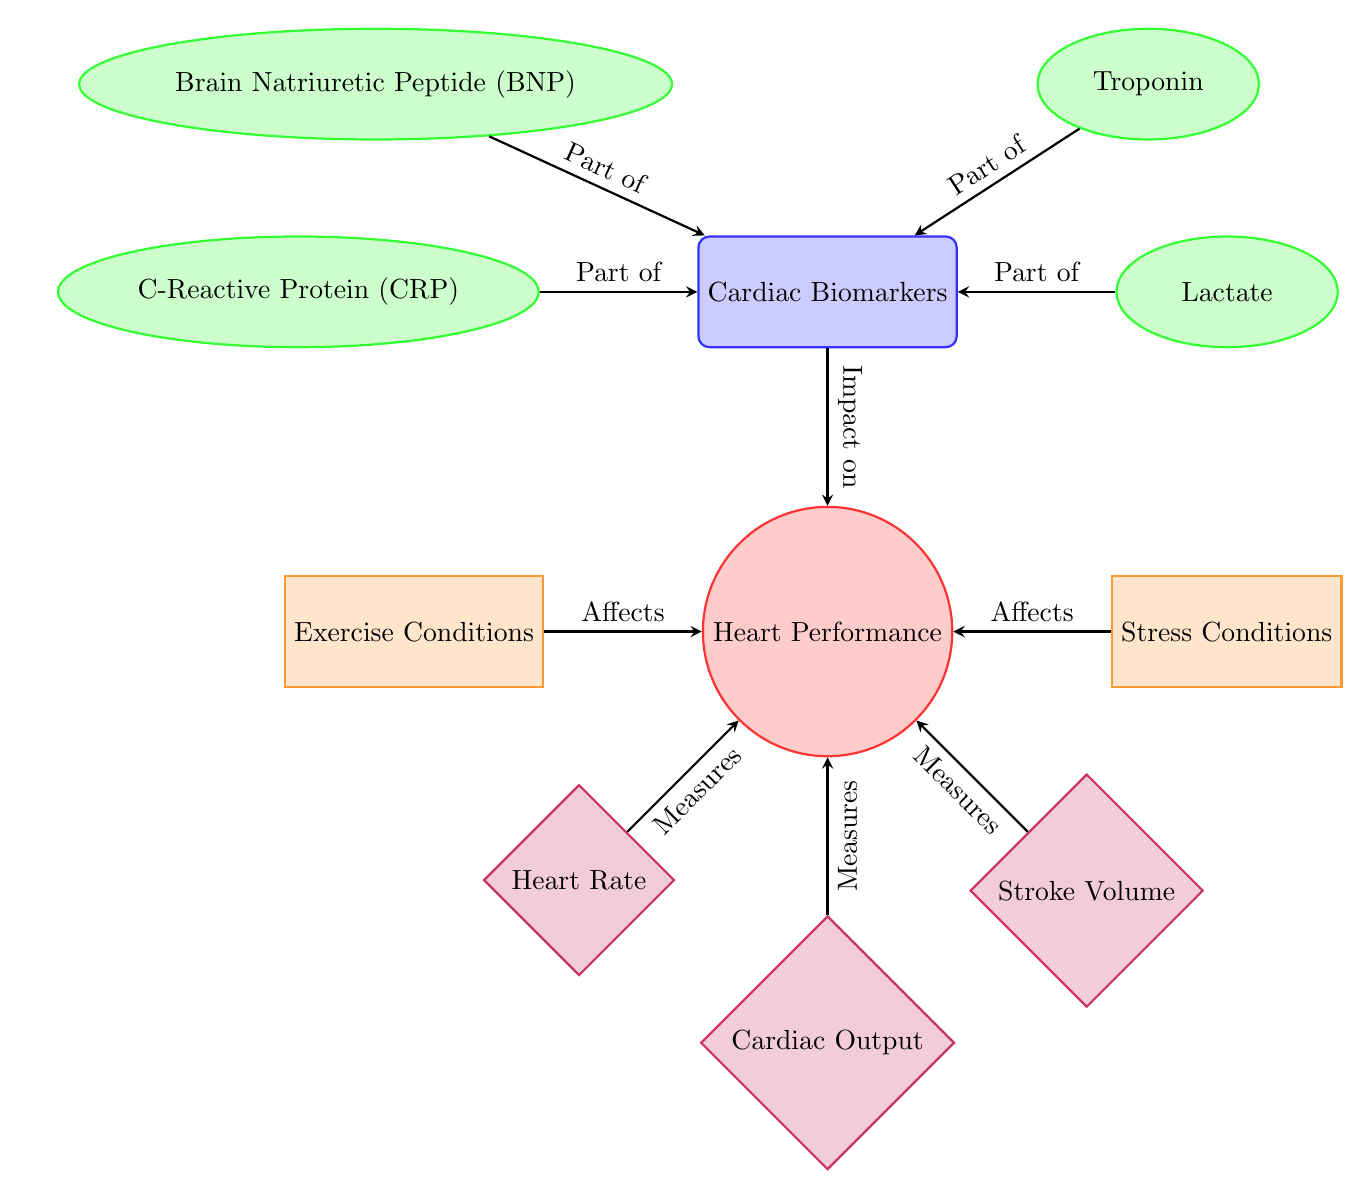What's the central node of the diagram? The diagram identifies "Heart Performance" as the central node, which is positioned prominently at the center.
Answer: Heart Performance How many cardiac biomarkers are listed in the diagram? There are four cardiac biomarkers indicated in the diagram: Brain Natriuretic Peptide (BNP), Troponin, C-Reactive Protein (CRP), and Lactate.
Answer: Four What does the "Heart Rate" measure? The diagram specifies that "Heart Rate" measures the central node, which signifies "Heart Performance".
Answer: Measures Which external condition affects heart performance according to the diagram? The diagram illustrates that both "Exercise Conditions" and "Stress Conditions" affect heart performance, indicating external influences on the heart's efficiency.
Answer: Exercise Conditions, Stress Conditions What is the relationship between "Cardiac Output" and "Heart Performance"? The diagram shows that "Cardiac Output" measures "Heart Performance", indicating a direct relationship where cardiac output is a factor in evaluating the heart's performance.
Answer: Measures Which cardiac biomarker is part of the biomarkers category? The diagram explicitly includes all listed biomarkers (BNP, Troponin, CRP, and Lactate) as part of the "Cardiac Biomarkers" category.
Answer: BNP, Troponin, CRP, Lactate What category do the nodes "Heart Rate", "Cardiac Output", and "Stroke Volume" belong to? These nodes are categorized under "Heart Performance", suggesting they are various measures related to the heart's functionality.
Answer: Performance Which arrow points from "Biomarkers" to "Heart Performance"? The arrow from "Cardiac Biomarkers" to "Heart Performance" indicates the impact of biomarkers on the performance of the heart.
Answer: Impact on What type of shape represents the cardiac biomarkers in the diagram? The diagram uses ellipses to represent the cardiac biomarkers, distinguishing them visually from other node types like the central and performance nodes.
Answer: Ellipse 